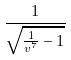Convert formula to latex. <formula><loc_0><loc_0><loc_500><loc_500>\frac { 1 } { \sqrt { \frac { 1 } { v ^ { 7 } } - 1 } }</formula> 